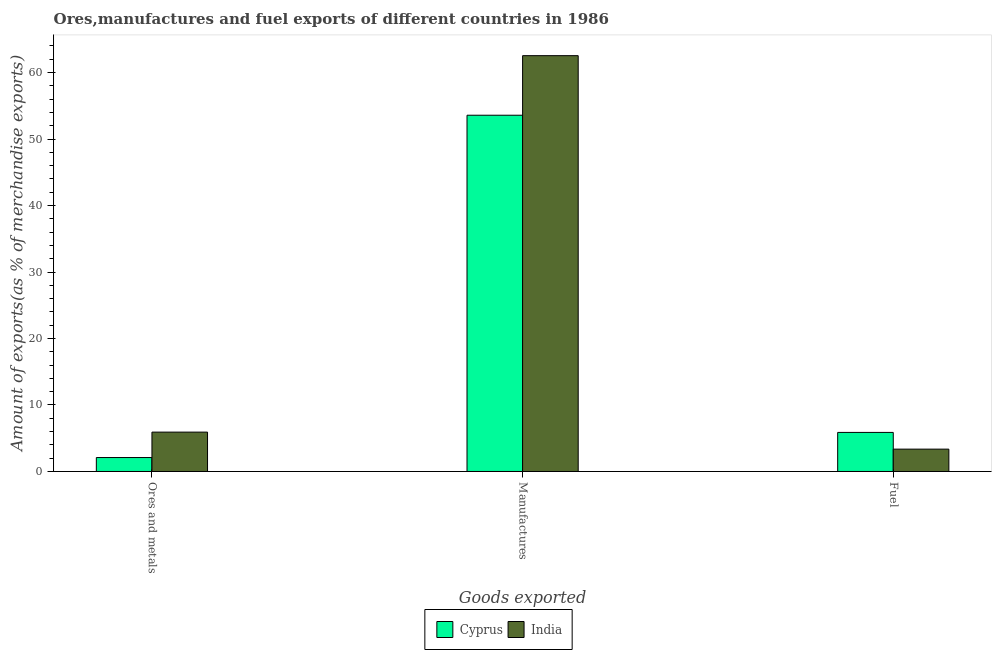What is the label of the 2nd group of bars from the left?
Your response must be concise. Manufactures. What is the percentage of fuel exports in Cyprus?
Your answer should be very brief. 5.88. Across all countries, what is the maximum percentage of ores and metals exports?
Give a very brief answer. 5.92. Across all countries, what is the minimum percentage of manufactures exports?
Offer a very short reply. 53.58. In which country was the percentage of fuel exports maximum?
Make the answer very short. Cyprus. In which country was the percentage of fuel exports minimum?
Ensure brevity in your answer.  India. What is the total percentage of fuel exports in the graph?
Give a very brief answer. 9.24. What is the difference between the percentage of fuel exports in Cyprus and that in India?
Your response must be concise. 2.51. What is the difference between the percentage of fuel exports in Cyprus and the percentage of ores and metals exports in India?
Offer a terse response. -0.05. What is the average percentage of ores and metals exports per country?
Offer a terse response. 4.01. What is the difference between the percentage of manufactures exports and percentage of fuel exports in Cyprus?
Keep it short and to the point. 47.71. In how many countries, is the percentage of manufactures exports greater than 48 %?
Your answer should be very brief. 2. What is the ratio of the percentage of fuel exports in India to that in Cyprus?
Your answer should be very brief. 0.57. Is the difference between the percentage of ores and metals exports in India and Cyprus greater than the difference between the percentage of fuel exports in India and Cyprus?
Offer a very short reply. Yes. What is the difference between the highest and the second highest percentage of fuel exports?
Your response must be concise. 2.51. What is the difference between the highest and the lowest percentage of ores and metals exports?
Ensure brevity in your answer.  3.82. In how many countries, is the percentage of fuel exports greater than the average percentage of fuel exports taken over all countries?
Your answer should be compact. 1. Is the sum of the percentage of fuel exports in India and Cyprus greater than the maximum percentage of manufactures exports across all countries?
Ensure brevity in your answer.  No. What does the 2nd bar from the left in Fuel represents?
Offer a terse response. India. What does the 1st bar from the right in Fuel represents?
Give a very brief answer. India. Is it the case that in every country, the sum of the percentage of ores and metals exports and percentage of manufactures exports is greater than the percentage of fuel exports?
Your answer should be compact. Yes. How many bars are there?
Keep it short and to the point. 6. What is the difference between two consecutive major ticks on the Y-axis?
Keep it short and to the point. 10. Does the graph contain grids?
Your answer should be compact. No. Where does the legend appear in the graph?
Offer a terse response. Bottom center. How many legend labels are there?
Offer a very short reply. 2. What is the title of the graph?
Offer a very short reply. Ores,manufactures and fuel exports of different countries in 1986. Does "Chile" appear as one of the legend labels in the graph?
Your response must be concise. No. What is the label or title of the X-axis?
Make the answer very short. Goods exported. What is the label or title of the Y-axis?
Ensure brevity in your answer.  Amount of exports(as % of merchandise exports). What is the Amount of exports(as % of merchandise exports) in Cyprus in Ores and metals?
Offer a terse response. 2.1. What is the Amount of exports(as % of merchandise exports) of India in Ores and metals?
Your answer should be very brief. 5.92. What is the Amount of exports(as % of merchandise exports) of Cyprus in Manufactures?
Your answer should be very brief. 53.58. What is the Amount of exports(as % of merchandise exports) in India in Manufactures?
Make the answer very short. 62.54. What is the Amount of exports(as % of merchandise exports) of Cyprus in Fuel?
Provide a succinct answer. 5.88. What is the Amount of exports(as % of merchandise exports) in India in Fuel?
Your response must be concise. 3.36. Across all Goods exported, what is the maximum Amount of exports(as % of merchandise exports) in Cyprus?
Keep it short and to the point. 53.58. Across all Goods exported, what is the maximum Amount of exports(as % of merchandise exports) in India?
Your answer should be very brief. 62.54. Across all Goods exported, what is the minimum Amount of exports(as % of merchandise exports) in Cyprus?
Ensure brevity in your answer.  2.1. Across all Goods exported, what is the minimum Amount of exports(as % of merchandise exports) in India?
Your response must be concise. 3.36. What is the total Amount of exports(as % of merchandise exports) in Cyprus in the graph?
Ensure brevity in your answer.  61.56. What is the total Amount of exports(as % of merchandise exports) of India in the graph?
Give a very brief answer. 71.83. What is the difference between the Amount of exports(as % of merchandise exports) of Cyprus in Ores and metals and that in Manufactures?
Ensure brevity in your answer.  -51.49. What is the difference between the Amount of exports(as % of merchandise exports) of India in Ores and metals and that in Manufactures?
Your answer should be very brief. -56.62. What is the difference between the Amount of exports(as % of merchandise exports) of Cyprus in Ores and metals and that in Fuel?
Your response must be concise. -3.78. What is the difference between the Amount of exports(as % of merchandise exports) of India in Ores and metals and that in Fuel?
Ensure brevity in your answer.  2.56. What is the difference between the Amount of exports(as % of merchandise exports) in Cyprus in Manufactures and that in Fuel?
Your answer should be compact. 47.71. What is the difference between the Amount of exports(as % of merchandise exports) of India in Manufactures and that in Fuel?
Your answer should be compact. 59.18. What is the difference between the Amount of exports(as % of merchandise exports) of Cyprus in Ores and metals and the Amount of exports(as % of merchandise exports) of India in Manufactures?
Your answer should be compact. -60.45. What is the difference between the Amount of exports(as % of merchandise exports) in Cyprus in Ores and metals and the Amount of exports(as % of merchandise exports) in India in Fuel?
Ensure brevity in your answer.  -1.27. What is the difference between the Amount of exports(as % of merchandise exports) of Cyprus in Manufactures and the Amount of exports(as % of merchandise exports) of India in Fuel?
Give a very brief answer. 50.22. What is the average Amount of exports(as % of merchandise exports) of Cyprus per Goods exported?
Your answer should be compact. 20.52. What is the average Amount of exports(as % of merchandise exports) of India per Goods exported?
Your answer should be very brief. 23.94. What is the difference between the Amount of exports(as % of merchandise exports) of Cyprus and Amount of exports(as % of merchandise exports) of India in Ores and metals?
Provide a succinct answer. -3.82. What is the difference between the Amount of exports(as % of merchandise exports) in Cyprus and Amount of exports(as % of merchandise exports) in India in Manufactures?
Provide a succinct answer. -8.96. What is the difference between the Amount of exports(as % of merchandise exports) in Cyprus and Amount of exports(as % of merchandise exports) in India in Fuel?
Make the answer very short. 2.51. What is the ratio of the Amount of exports(as % of merchandise exports) of Cyprus in Ores and metals to that in Manufactures?
Provide a short and direct response. 0.04. What is the ratio of the Amount of exports(as % of merchandise exports) in India in Ores and metals to that in Manufactures?
Your answer should be compact. 0.09. What is the ratio of the Amount of exports(as % of merchandise exports) of Cyprus in Ores and metals to that in Fuel?
Offer a very short reply. 0.36. What is the ratio of the Amount of exports(as % of merchandise exports) in India in Ores and metals to that in Fuel?
Keep it short and to the point. 1.76. What is the ratio of the Amount of exports(as % of merchandise exports) in Cyprus in Manufactures to that in Fuel?
Provide a short and direct response. 9.12. What is the ratio of the Amount of exports(as % of merchandise exports) in India in Manufactures to that in Fuel?
Your answer should be very brief. 18.6. What is the difference between the highest and the second highest Amount of exports(as % of merchandise exports) in Cyprus?
Give a very brief answer. 47.71. What is the difference between the highest and the second highest Amount of exports(as % of merchandise exports) in India?
Provide a succinct answer. 56.62. What is the difference between the highest and the lowest Amount of exports(as % of merchandise exports) of Cyprus?
Keep it short and to the point. 51.49. What is the difference between the highest and the lowest Amount of exports(as % of merchandise exports) of India?
Your response must be concise. 59.18. 